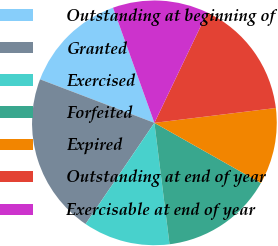<chart> <loc_0><loc_0><loc_500><loc_500><pie_chart><fcel>Outstanding at beginning of<fcel>Granted<fcel>Exercised<fcel>Forfeited<fcel>Expired<fcel>Outstanding at end of year<fcel>Exercisable at end of year<nl><fcel>13.72%<fcel>21.28%<fcel>11.48%<fcel>14.84%<fcel>10.12%<fcel>15.95%<fcel>12.6%<nl></chart> 